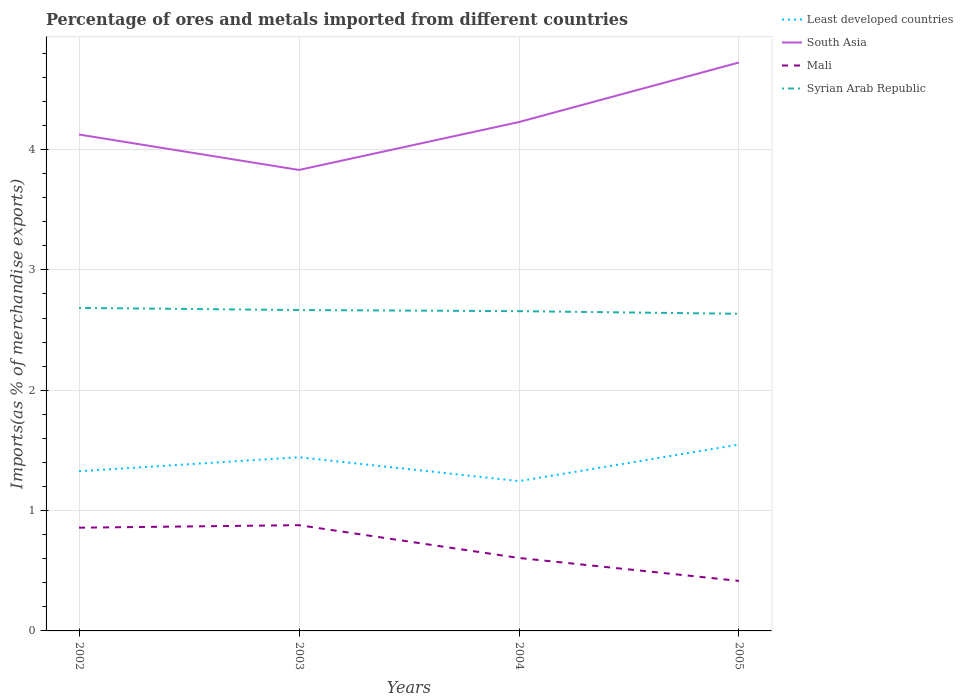How many different coloured lines are there?
Ensure brevity in your answer.  4. Is the number of lines equal to the number of legend labels?
Your response must be concise. Yes. Across all years, what is the maximum percentage of imports to different countries in Syrian Arab Republic?
Offer a very short reply. 2.64. In which year was the percentage of imports to different countries in Least developed countries maximum?
Your answer should be compact. 2004. What is the total percentage of imports to different countries in South Asia in the graph?
Your answer should be compact. -0.6. What is the difference between the highest and the second highest percentage of imports to different countries in South Asia?
Offer a terse response. 0.89. Is the percentage of imports to different countries in Mali strictly greater than the percentage of imports to different countries in Syrian Arab Republic over the years?
Offer a very short reply. Yes. How many years are there in the graph?
Your response must be concise. 4. What is the difference between two consecutive major ticks on the Y-axis?
Ensure brevity in your answer.  1. Are the values on the major ticks of Y-axis written in scientific E-notation?
Provide a short and direct response. No. Does the graph contain grids?
Ensure brevity in your answer.  Yes. Where does the legend appear in the graph?
Provide a short and direct response. Top right. What is the title of the graph?
Offer a very short reply. Percentage of ores and metals imported from different countries. Does "Uzbekistan" appear as one of the legend labels in the graph?
Keep it short and to the point. No. What is the label or title of the Y-axis?
Give a very brief answer. Imports(as % of merchandise exports). What is the Imports(as % of merchandise exports) of Least developed countries in 2002?
Keep it short and to the point. 1.33. What is the Imports(as % of merchandise exports) in South Asia in 2002?
Your response must be concise. 4.13. What is the Imports(as % of merchandise exports) of Mali in 2002?
Offer a terse response. 0.86. What is the Imports(as % of merchandise exports) of Syrian Arab Republic in 2002?
Your response must be concise. 2.68. What is the Imports(as % of merchandise exports) of Least developed countries in 2003?
Give a very brief answer. 1.44. What is the Imports(as % of merchandise exports) in South Asia in 2003?
Provide a short and direct response. 3.83. What is the Imports(as % of merchandise exports) of Mali in 2003?
Provide a succinct answer. 0.88. What is the Imports(as % of merchandise exports) of Syrian Arab Republic in 2003?
Your answer should be compact. 2.67. What is the Imports(as % of merchandise exports) of Least developed countries in 2004?
Offer a terse response. 1.24. What is the Imports(as % of merchandise exports) of South Asia in 2004?
Keep it short and to the point. 4.23. What is the Imports(as % of merchandise exports) of Mali in 2004?
Your answer should be compact. 0.61. What is the Imports(as % of merchandise exports) of Syrian Arab Republic in 2004?
Provide a short and direct response. 2.66. What is the Imports(as % of merchandise exports) of Least developed countries in 2005?
Make the answer very short. 1.55. What is the Imports(as % of merchandise exports) of South Asia in 2005?
Provide a succinct answer. 4.72. What is the Imports(as % of merchandise exports) in Mali in 2005?
Your answer should be compact. 0.42. What is the Imports(as % of merchandise exports) of Syrian Arab Republic in 2005?
Offer a very short reply. 2.64. Across all years, what is the maximum Imports(as % of merchandise exports) of Least developed countries?
Keep it short and to the point. 1.55. Across all years, what is the maximum Imports(as % of merchandise exports) of South Asia?
Your response must be concise. 4.72. Across all years, what is the maximum Imports(as % of merchandise exports) in Mali?
Offer a terse response. 0.88. Across all years, what is the maximum Imports(as % of merchandise exports) in Syrian Arab Republic?
Make the answer very short. 2.68. Across all years, what is the minimum Imports(as % of merchandise exports) of Least developed countries?
Give a very brief answer. 1.24. Across all years, what is the minimum Imports(as % of merchandise exports) in South Asia?
Make the answer very short. 3.83. Across all years, what is the minimum Imports(as % of merchandise exports) in Mali?
Your answer should be very brief. 0.42. Across all years, what is the minimum Imports(as % of merchandise exports) in Syrian Arab Republic?
Your answer should be compact. 2.64. What is the total Imports(as % of merchandise exports) of Least developed countries in the graph?
Offer a terse response. 5.56. What is the total Imports(as % of merchandise exports) in South Asia in the graph?
Offer a terse response. 16.91. What is the total Imports(as % of merchandise exports) of Mali in the graph?
Make the answer very short. 2.76. What is the total Imports(as % of merchandise exports) in Syrian Arab Republic in the graph?
Keep it short and to the point. 10.64. What is the difference between the Imports(as % of merchandise exports) in Least developed countries in 2002 and that in 2003?
Keep it short and to the point. -0.12. What is the difference between the Imports(as % of merchandise exports) in South Asia in 2002 and that in 2003?
Offer a very short reply. 0.29. What is the difference between the Imports(as % of merchandise exports) in Mali in 2002 and that in 2003?
Your answer should be compact. -0.02. What is the difference between the Imports(as % of merchandise exports) of Syrian Arab Republic in 2002 and that in 2003?
Ensure brevity in your answer.  0.02. What is the difference between the Imports(as % of merchandise exports) in Least developed countries in 2002 and that in 2004?
Your answer should be compact. 0.08. What is the difference between the Imports(as % of merchandise exports) of South Asia in 2002 and that in 2004?
Make the answer very short. -0.1. What is the difference between the Imports(as % of merchandise exports) in Mali in 2002 and that in 2004?
Your response must be concise. 0.25. What is the difference between the Imports(as % of merchandise exports) of Syrian Arab Republic in 2002 and that in 2004?
Provide a short and direct response. 0.03. What is the difference between the Imports(as % of merchandise exports) of Least developed countries in 2002 and that in 2005?
Keep it short and to the point. -0.22. What is the difference between the Imports(as % of merchandise exports) in South Asia in 2002 and that in 2005?
Your response must be concise. -0.6. What is the difference between the Imports(as % of merchandise exports) in Mali in 2002 and that in 2005?
Your response must be concise. 0.44. What is the difference between the Imports(as % of merchandise exports) in Syrian Arab Republic in 2002 and that in 2005?
Keep it short and to the point. 0.05. What is the difference between the Imports(as % of merchandise exports) in Least developed countries in 2003 and that in 2004?
Make the answer very short. 0.2. What is the difference between the Imports(as % of merchandise exports) in South Asia in 2003 and that in 2004?
Give a very brief answer. -0.4. What is the difference between the Imports(as % of merchandise exports) of Mali in 2003 and that in 2004?
Your answer should be compact. 0.27. What is the difference between the Imports(as % of merchandise exports) of Syrian Arab Republic in 2003 and that in 2004?
Your answer should be compact. 0.01. What is the difference between the Imports(as % of merchandise exports) in Least developed countries in 2003 and that in 2005?
Your response must be concise. -0.11. What is the difference between the Imports(as % of merchandise exports) in South Asia in 2003 and that in 2005?
Provide a succinct answer. -0.89. What is the difference between the Imports(as % of merchandise exports) of Mali in 2003 and that in 2005?
Your response must be concise. 0.46. What is the difference between the Imports(as % of merchandise exports) of Syrian Arab Republic in 2003 and that in 2005?
Offer a very short reply. 0.03. What is the difference between the Imports(as % of merchandise exports) of Least developed countries in 2004 and that in 2005?
Your answer should be compact. -0.3. What is the difference between the Imports(as % of merchandise exports) in South Asia in 2004 and that in 2005?
Offer a terse response. -0.49. What is the difference between the Imports(as % of merchandise exports) in Mali in 2004 and that in 2005?
Provide a short and direct response. 0.19. What is the difference between the Imports(as % of merchandise exports) in Syrian Arab Republic in 2004 and that in 2005?
Your response must be concise. 0.02. What is the difference between the Imports(as % of merchandise exports) in Least developed countries in 2002 and the Imports(as % of merchandise exports) in South Asia in 2003?
Offer a very short reply. -2.5. What is the difference between the Imports(as % of merchandise exports) of Least developed countries in 2002 and the Imports(as % of merchandise exports) of Mali in 2003?
Keep it short and to the point. 0.45. What is the difference between the Imports(as % of merchandise exports) in Least developed countries in 2002 and the Imports(as % of merchandise exports) in Syrian Arab Republic in 2003?
Keep it short and to the point. -1.34. What is the difference between the Imports(as % of merchandise exports) in South Asia in 2002 and the Imports(as % of merchandise exports) in Mali in 2003?
Offer a terse response. 3.25. What is the difference between the Imports(as % of merchandise exports) in South Asia in 2002 and the Imports(as % of merchandise exports) in Syrian Arab Republic in 2003?
Your answer should be very brief. 1.46. What is the difference between the Imports(as % of merchandise exports) in Mali in 2002 and the Imports(as % of merchandise exports) in Syrian Arab Republic in 2003?
Give a very brief answer. -1.81. What is the difference between the Imports(as % of merchandise exports) of Least developed countries in 2002 and the Imports(as % of merchandise exports) of South Asia in 2004?
Provide a short and direct response. -2.9. What is the difference between the Imports(as % of merchandise exports) in Least developed countries in 2002 and the Imports(as % of merchandise exports) in Mali in 2004?
Your response must be concise. 0.72. What is the difference between the Imports(as % of merchandise exports) in Least developed countries in 2002 and the Imports(as % of merchandise exports) in Syrian Arab Republic in 2004?
Give a very brief answer. -1.33. What is the difference between the Imports(as % of merchandise exports) in South Asia in 2002 and the Imports(as % of merchandise exports) in Mali in 2004?
Provide a short and direct response. 3.52. What is the difference between the Imports(as % of merchandise exports) in South Asia in 2002 and the Imports(as % of merchandise exports) in Syrian Arab Republic in 2004?
Your response must be concise. 1.47. What is the difference between the Imports(as % of merchandise exports) of Mali in 2002 and the Imports(as % of merchandise exports) of Syrian Arab Republic in 2004?
Your response must be concise. -1.8. What is the difference between the Imports(as % of merchandise exports) of Least developed countries in 2002 and the Imports(as % of merchandise exports) of South Asia in 2005?
Your response must be concise. -3.4. What is the difference between the Imports(as % of merchandise exports) of Least developed countries in 2002 and the Imports(as % of merchandise exports) of Mali in 2005?
Your answer should be compact. 0.91. What is the difference between the Imports(as % of merchandise exports) of Least developed countries in 2002 and the Imports(as % of merchandise exports) of Syrian Arab Republic in 2005?
Offer a terse response. -1.31. What is the difference between the Imports(as % of merchandise exports) of South Asia in 2002 and the Imports(as % of merchandise exports) of Mali in 2005?
Provide a short and direct response. 3.71. What is the difference between the Imports(as % of merchandise exports) in South Asia in 2002 and the Imports(as % of merchandise exports) in Syrian Arab Republic in 2005?
Provide a succinct answer. 1.49. What is the difference between the Imports(as % of merchandise exports) in Mali in 2002 and the Imports(as % of merchandise exports) in Syrian Arab Republic in 2005?
Your response must be concise. -1.78. What is the difference between the Imports(as % of merchandise exports) in Least developed countries in 2003 and the Imports(as % of merchandise exports) in South Asia in 2004?
Keep it short and to the point. -2.79. What is the difference between the Imports(as % of merchandise exports) in Least developed countries in 2003 and the Imports(as % of merchandise exports) in Mali in 2004?
Offer a terse response. 0.84. What is the difference between the Imports(as % of merchandise exports) in Least developed countries in 2003 and the Imports(as % of merchandise exports) in Syrian Arab Republic in 2004?
Your answer should be very brief. -1.21. What is the difference between the Imports(as % of merchandise exports) in South Asia in 2003 and the Imports(as % of merchandise exports) in Mali in 2004?
Provide a short and direct response. 3.22. What is the difference between the Imports(as % of merchandise exports) of South Asia in 2003 and the Imports(as % of merchandise exports) of Syrian Arab Republic in 2004?
Make the answer very short. 1.17. What is the difference between the Imports(as % of merchandise exports) in Mali in 2003 and the Imports(as % of merchandise exports) in Syrian Arab Republic in 2004?
Your response must be concise. -1.78. What is the difference between the Imports(as % of merchandise exports) of Least developed countries in 2003 and the Imports(as % of merchandise exports) of South Asia in 2005?
Offer a terse response. -3.28. What is the difference between the Imports(as % of merchandise exports) in Least developed countries in 2003 and the Imports(as % of merchandise exports) in Mali in 2005?
Make the answer very short. 1.03. What is the difference between the Imports(as % of merchandise exports) of Least developed countries in 2003 and the Imports(as % of merchandise exports) of Syrian Arab Republic in 2005?
Offer a very short reply. -1.19. What is the difference between the Imports(as % of merchandise exports) of South Asia in 2003 and the Imports(as % of merchandise exports) of Mali in 2005?
Make the answer very short. 3.42. What is the difference between the Imports(as % of merchandise exports) of South Asia in 2003 and the Imports(as % of merchandise exports) of Syrian Arab Republic in 2005?
Offer a very short reply. 1.2. What is the difference between the Imports(as % of merchandise exports) of Mali in 2003 and the Imports(as % of merchandise exports) of Syrian Arab Republic in 2005?
Ensure brevity in your answer.  -1.76. What is the difference between the Imports(as % of merchandise exports) in Least developed countries in 2004 and the Imports(as % of merchandise exports) in South Asia in 2005?
Provide a succinct answer. -3.48. What is the difference between the Imports(as % of merchandise exports) in Least developed countries in 2004 and the Imports(as % of merchandise exports) in Mali in 2005?
Keep it short and to the point. 0.83. What is the difference between the Imports(as % of merchandise exports) of Least developed countries in 2004 and the Imports(as % of merchandise exports) of Syrian Arab Republic in 2005?
Offer a very short reply. -1.39. What is the difference between the Imports(as % of merchandise exports) in South Asia in 2004 and the Imports(as % of merchandise exports) in Mali in 2005?
Your answer should be compact. 3.81. What is the difference between the Imports(as % of merchandise exports) in South Asia in 2004 and the Imports(as % of merchandise exports) in Syrian Arab Republic in 2005?
Keep it short and to the point. 1.59. What is the difference between the Imports(as % of merchandise exports) in Mali in 2004 and the Imports(as % of merchandise exports) in Syrian Arab Republic in 2005?
Your answer should be compact. -2.03. What is the average Imports(as % of merchandise exports) of Least developed countries per year?
Your response must be concise. 1.39. What is the average Imports(as % of merchandise exports) in South Asia per year?
Your answer should be compact. 4.23. What is the average Imports(as % of merchandise exports) in Mali per year?
Provide a succinct answer. 0.69. What is the average Imports(as % of merchandise exports) in Syrian Arab Republic per year?
Offer a very short reply. 2.66. In the year 2002, what is the difference between the Imports(as % of merchandise exports) in Least developed countries and Imports(as % of merchandise exports) in South Asia?
Ensure brevity in your answer.  -2.8. In the year 2002, what is the difference between the Imports(as % of merchandise exports) in Least developed countries and Imports(as % of merchandise exports) in Mali?
Ensure brevity in your answer.  0.47. In the year 2002, what is the difference between the Imports(as % of merchandise exports) of Least developed countries and Imports(as % of merchandise exports) of Syrian Arab Republic?
Give a very brief answer. -1.36. In the year 2002, what is the difference between the Imports(as % of merchandise exports) in South Asia and Imports(as % of merchandise exports) in Mali?
Make the answer very short. 3.27. In the year 2002, what is the difference between the Imports(as % of merchandise exports) in South Asia and Imports(as % of merchandise exports) in Syrian Arab Republic?
Ensure brevity in your answer.  1.44. In the year 2002, what is the difference between the Imports(as % of merchandise exports) of Mali and Imports(as % of merchandise exports) of Syrian Arab Republic?
Your answer should be very brief. -1.83. In the year 2003, what is the difference between the Imports(as % of merchandise exports) in Least developed countries and Imports(as % of merchandise exports) in South Asia?
Give a very brief answer. -2.39. In the year 2003, what is the difference between the Imports(as % of merchandise exports) of Least developed countries and Imports(as % of merchandise exports) of Mali?
Offer a very short reply. 0.56. In the year 2003, what is the difference between the Imports(as % of merchandise exports) in Least developed countries and Imports(as % of merchandise exports) in Syrian Arab Republic?
Provide a short and direct response. -1.22. In the year 2003, what is the difference between the Imports(as % of merchandise exports) in South Asia and Imports(as % of merchandise exports) in Mali?
Your response must be concise. 2.95. In the year 2003, what is the difference between the Imports(as % of merchandise exports) of South Asia and Imports(as % of merchandise exports) of Syrian Arab Republic?
Ensure brevity in your answer.  1.16. In the year 2003, what is the difference between the Imports(as % of merchandise exports) of Mali and Imports(as % of merchandise exports) of Syrian Arab Republic?
Keep it short and to the point. -1.79. In the year 2004, what is the difference between the Imports(as % of merchandise exports) of Least developed countries and Imports(as % of merchandise exports) of South Asia?
Keep it short and to the point. -2.98. In the year 2004, what is the difference between the Imports(as % of merchandise exports) in Least developed countries and Imports(as % of merchandise exports) in Mali?
Your answer should be very brief. 0.64. In the year 2004, what is the difference between the Imports(as % of merchandise exports) in Least developed countries and Imports(as % of merchandise exports) in Syrian Arab Republic?
Provide a short and direct response. -1.41. In the year 2004, what is the difference between the Imports(as % of merchandise exports) of South Asia and Imports(as % of merchandise exports) of Mali?
Make the answer very short. 3.62. In the year 2004, what is the difference between the Imports(as % of merchandise exports) in South Asia and Imports(as % of merchandise exports) in Syrian Arab Republic?
Offer a terse response. 1.57. In the year 2004, what is the difference between the Imports(as % of merchandise exports) in Mali and Imports(as % of merchandise exports) in Syrian Arab Republic?
Your answer should be compact. -2.05. In the year 2005, what is the difference between the Imports(as % of merchandise exports) in Least developed countries and Imports(as % of merchandise exports) in South Asia?
Your answer should be very brief. -3.18. In the year 2005, what is the difference between the Imports(as % of merchandise exports) of Least developed countries and Imports(as % of merchandise exports) of Mali?
Your answer should be very brief. 1.13. In the year 2005, what is the difference between the Imports(as % of merchandise exports) of Least developed countries and Imports(as % of merchandise exports) of Syrian Arab Republic?
Ensure brevity in your answer.  -1.09. In the year 2005, what is the difference between the Imports(as % of merchandise exports) in South Asia and Imports(as % of merchandise exports) in Mali?
Give a very brief answer. 4.31. In the year 2005, what is the difference between the Imports(as % of merchandise exports) in South Asia and Imports(as % of merchandise exports) in Syrian Arab Republic?
Offer a terse response. 2.09. In the year 2005, what is the difference between the Imports(as % of merchandise exports) of Mali and Imports(as % of merchandise exports) of Syrian Arab Republic?
Ensure brevity in your answer.  -2.22. What is the ratio of the Imports(as % of merchandise exports) in Least developed countries in 2002 to that in 2003?
Provide a succinct answer. 0.92. What is the ratio of the Imports(as % of merchandise exports) in Mali in 2002 to that in 2003?
Ensure brevity in your answer.  0.98. What is the ratio of the Imports(as % of merchandise exports) in Syrian Arab Republic in 2002 to that in 2003?
Provide a short and direct response. 1.01. What is the ratio of the Imports(as % of merchandise exports) of Least developed countries in 2002 to that in 2004?
Keep it short and to the point. 1.07. What is the ratio of the Imports(as % of merchandise exports) in South Asia in 2002 to that in 2004?
Offer a very short reply. 0.98. What is the ratio of the Imports(as % of merchandise exports) in Mali in 2002 to that in 2004?
Ensure brevity in your answer.  1.42. What is the ratio of the Imports(as % of merchandise exports) in Syrian Arab Republic in 2002 to that in 2004?
Make the answer very short. 1.01. What is the ratio of the Imports(as % of merchandise exports) of South Asia in 2002 to that in 2005?
Your answer should be very brief. 0.87. What is the ratio of the Imports(as % of merchandise exports) in Mali in 2002 to that in 2005?
Keep it short and to the point. 2.06. What is the ratio of the Imports(as % of merchandise exports) of Syrian Arab Republic in 2002 to that in 2005?
Offer a very short reply. 1.02. What is the ratio of the Imports(as % of merchandise exports) of Least developed countries in 2003 to that in 2004?
Your answer should be very brief. 1.16. What is the ratio of the Imports(as % of merchandise exports) in South Asia in 2003 to that in 2004?
Keep it short and to the point. 0.91. What is the ratio of the Imports(as % of merchandise exports) of Mali in 2003 to that in 2004?
Your response must be concise. 1.45. What is the ratio of the Imports(as % of merchandise exports) in Least developed countries in 2003 to that in 2005?
Ensure brevity in your answer.  0.93. What is the ratio of the Imports(as % of merchandise exports) in South Asia in 2003 to that in 2005?
Keep it short and to the point. 0.81. What is the ratio of the Imports(as % of merchandise exports) of Mali in 2003 to that in 2005?
Give a very brief answer. 2.11. What is the ratio of the Imports(as % of merchandise exports) in Syrian Arab Republic in 2003 to that in 2005?
Provide a succinct answer. 1.01. What is the ratio of the Imports(as % of merchandise exports) of Least developed countries in 2004 to that in 2005?
Provide a short and direct response. 0.8. What is the ratio of the Imports(as % of merchandise exports) in South Asia in 2004 to that in 2005?
Your answer should be compact. 0.9. What is the ratio of the Imports(as % of merchandise exports) in Mali in 2004 to that in 2005?
Make the answer very short. 1.46. What is the ratio of the Imports(as % of merchandise exports) of Syrian Arab Republic in 2004 to that in 2005?
Offer a very short reply. 1.01. What is the difference between the highest and the second highest Imports(as % of merchandise exports) in Least developed countries?
Make the answer very short. 0.11. What is the difference between the highest and the second highest Imports(as % of merchandise exports) of South Asia?
Provide a short and direct response. 0.49. What is the difference between the highest and the second highest Imports(as % of merchandise exports) in Mali?
Your answer should be very brief. 0.02. What is the difference between the highest and the second highest Imports(as % of merchandise exports) of Syrian Arab Republic?
Offer a terse response. 0.02. What is the difference between the highest and the lowest Imports(as % of merchandise exports) in Least developed countries?
Provide a succinct answer. 0.3. What is the difference between the highest and the lowest Imports(as % of merchandise exports) of South Asia?
Keep it short and to the point. 0.89. What is the difference between the highest and the lowest Imports(as % of merchandise exports) in Mali?
Offer a very short reply. 0.46. What is the difference between the highest and the lowest Imports(as % of merchandise exports) in Syrian Arab Republic?
Your answer should be very brief. 0.05. 